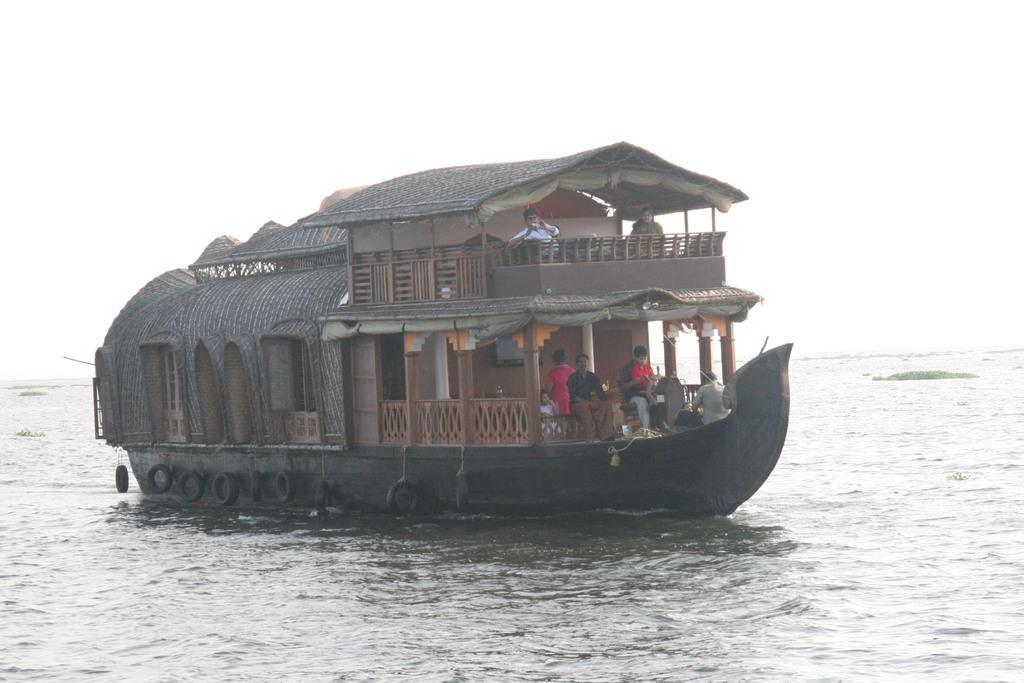Describe this image in one or two sentences. In this image we can see there is a ship on the water and there are persons in it and holding an object. And there are tires tied to it. 